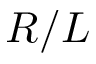Convert formula to latex. <formula><loc_0><loc_0><loc_500><loc_500>R / L</formula> 